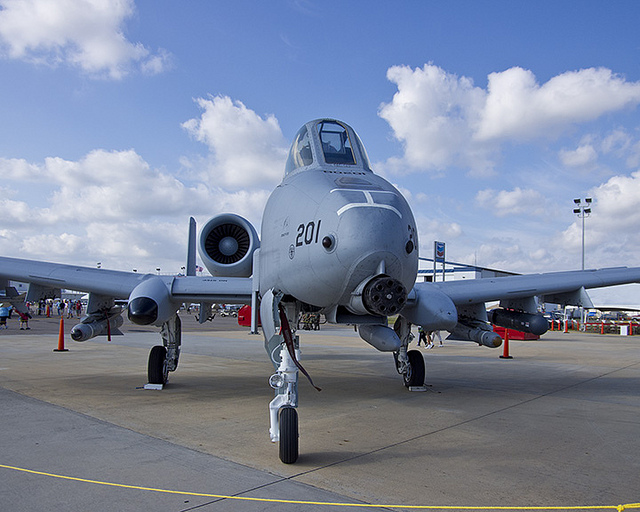Please transcribe the text information in this image. 201 